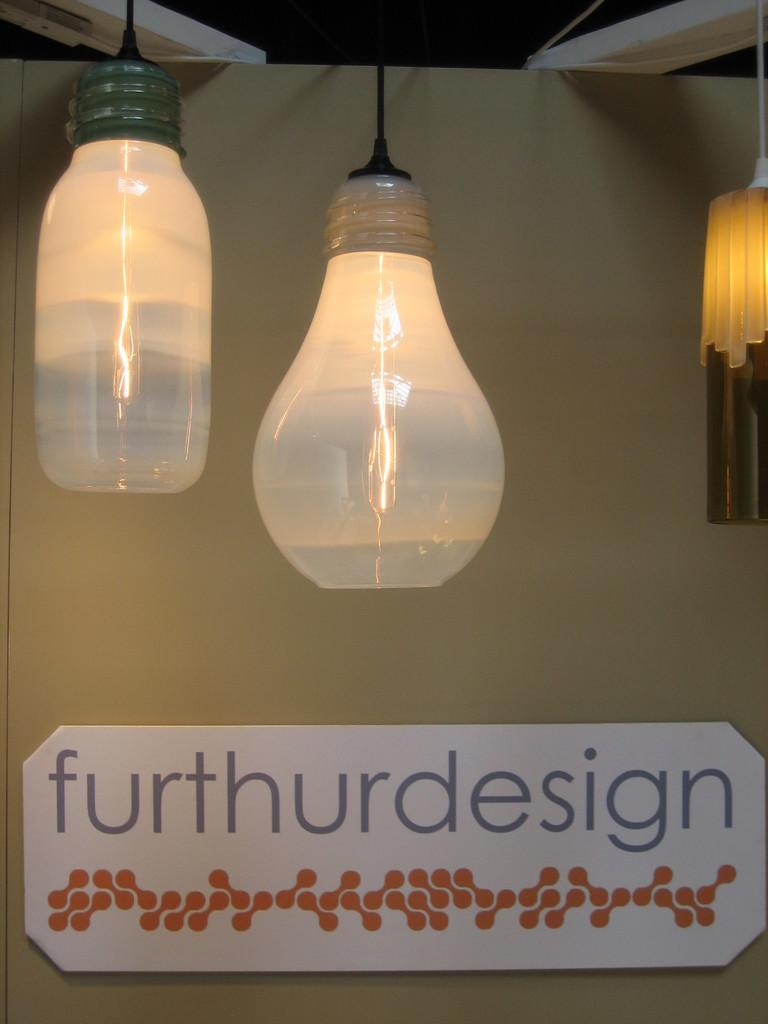<image>
Summarize the visual content of the image. Large bulb above a sign which says furthurdesign. 